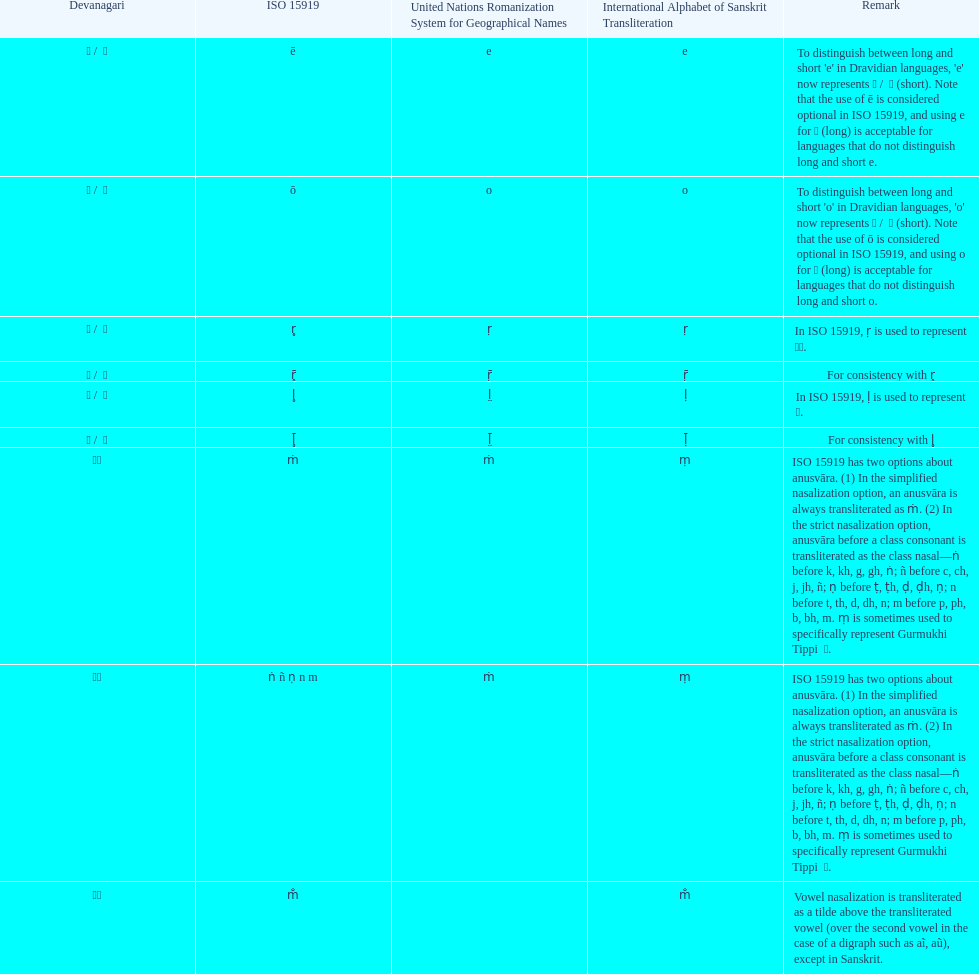What is listed previous to in iso 15919, &#7735; is used to represent &#2355;. under comments? For consistency with r̥. 